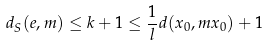Convert formula to latex. <formula><loc_0><loc_0><loc_500><loc_500>d _ { S } ( e , m ) \leq k + 1 \leq \frac { 1 } { l } d ( x _ { 0 } , m x _ { 0 } ) + 1</formula> 